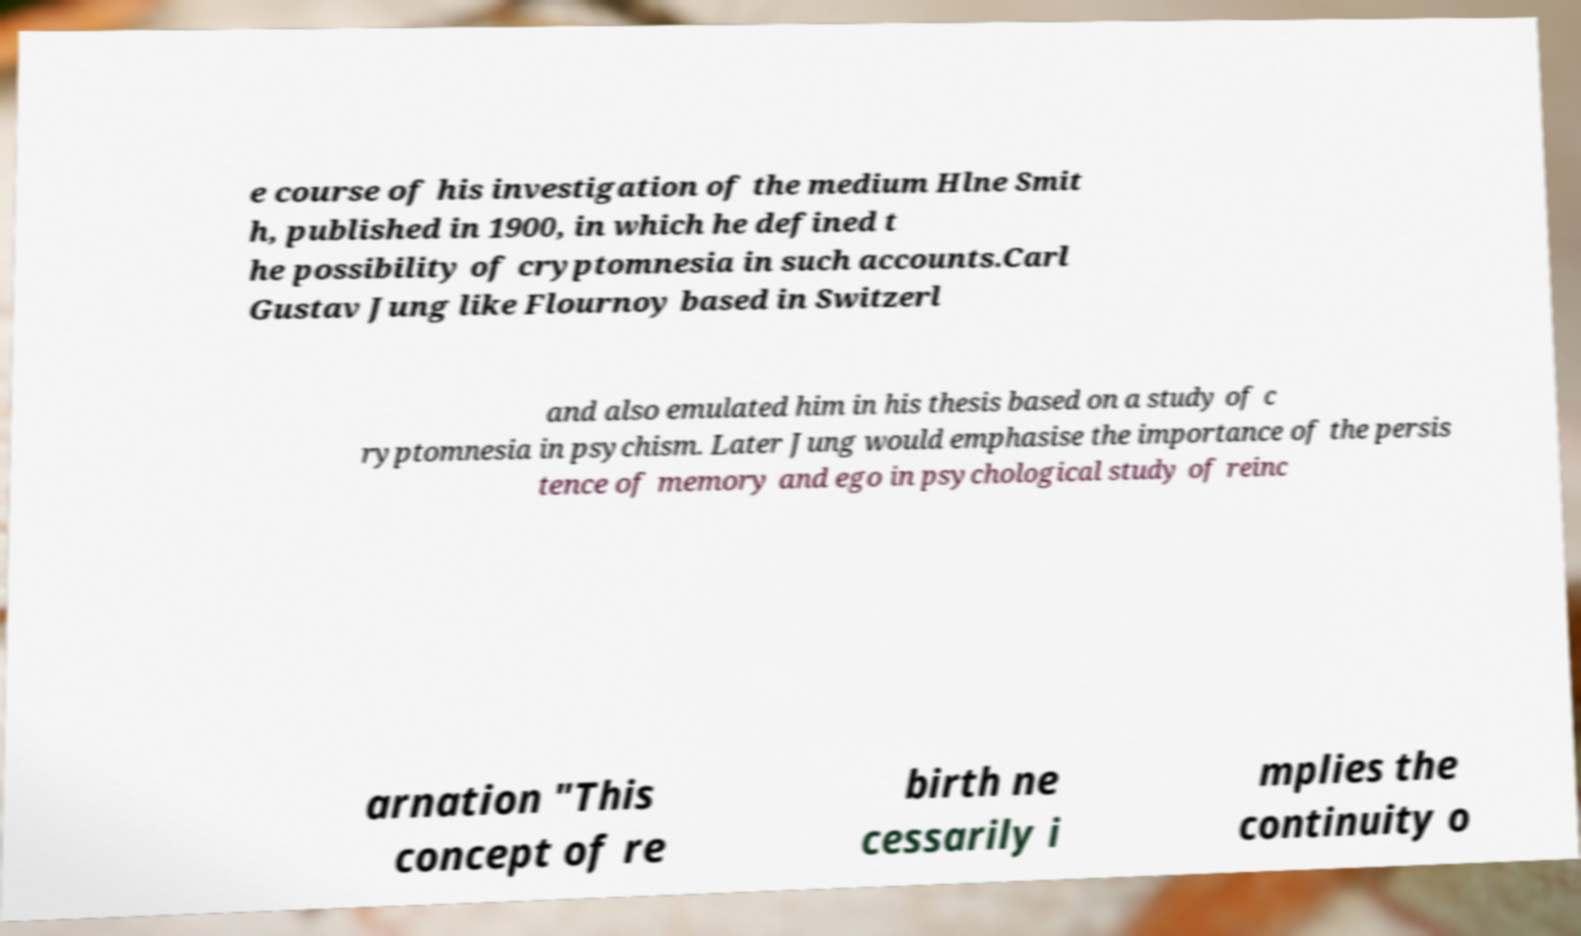I need the written content from this picture converted into text. Can you do that? e course of his investigation of the medium Hlne Smit h, published in 1900, in which he defined t he possibility of cryptomnesia in such accounts.Carl Gustav Jung like Flournoy based in Switzerl and also emulated him in his thesis based on a study of c ryptomnesia in psychism. Later Jung would emphasise the importance of the persis tence of memory and ego in psychological study of reinc arnation "This concept of re birth ne cessarily i mplies the continuity o 